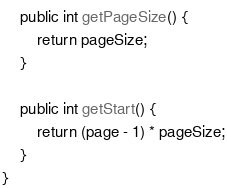<code> <loc_0><loc_0><loc_500><loc_500><_Java_>
    public int getPageSize() {
        return pageSize;
    }

    public int getStart() {
        return (page - 1) * pageSize;
    }
}
</code> 